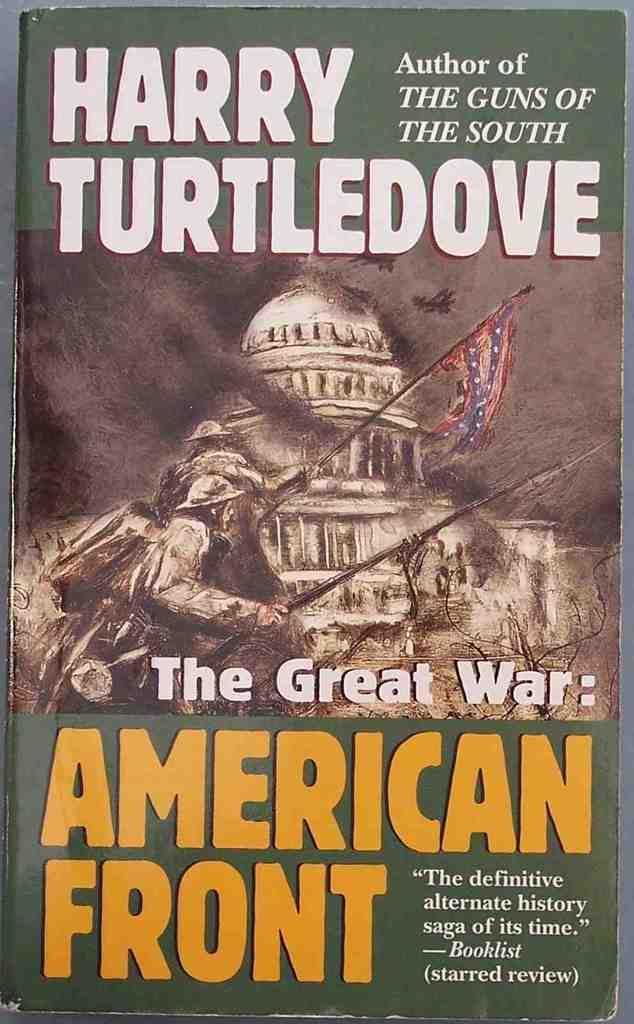<image>
Relay a brief, clear account of the picture shown. a magazine cover that reads The American Front 